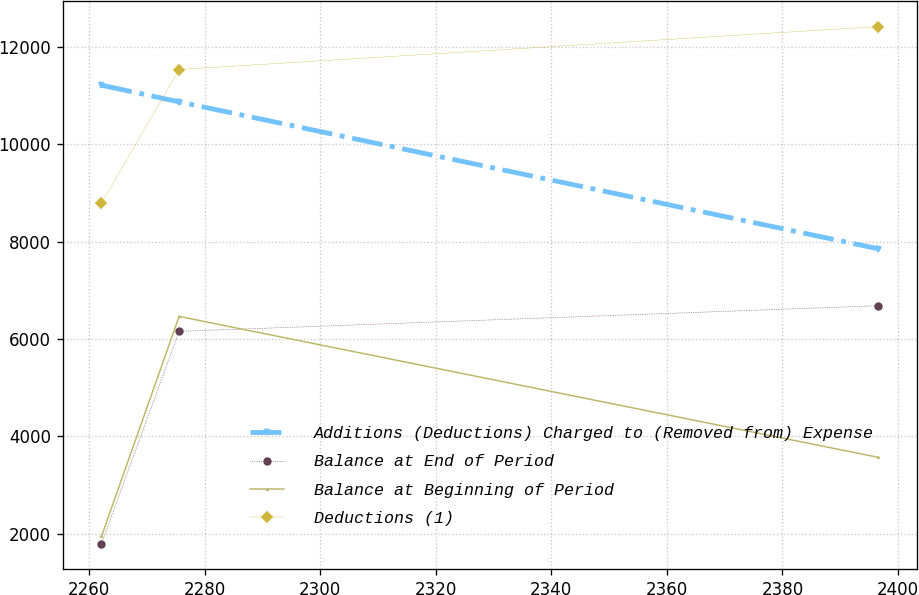Convert chart to OTSL. <chart><loc_0><loc_0><loc_500><loc_500><line_chart><ecel><fcel>Additions (Deductions) Charged to (Removed from) Expense<fcel>Balance at End of Period<fcel>Balance at Beginning of Period<fcel>Deductions (1)<nl><fcel>2262.14<fcel>11217.4<fcel>1796.72<fcel>1943.19<fcel>8790.84<nl><fcel>2275.58<fcel>10874.5<fcel>6158.11<fcel>6464.87<fcel>11539.7<nl><fcel>2396.57<fcel>7855.74<fcel>6685.06<fcel>3569.24<fcel>12422.5<nl></chart> 